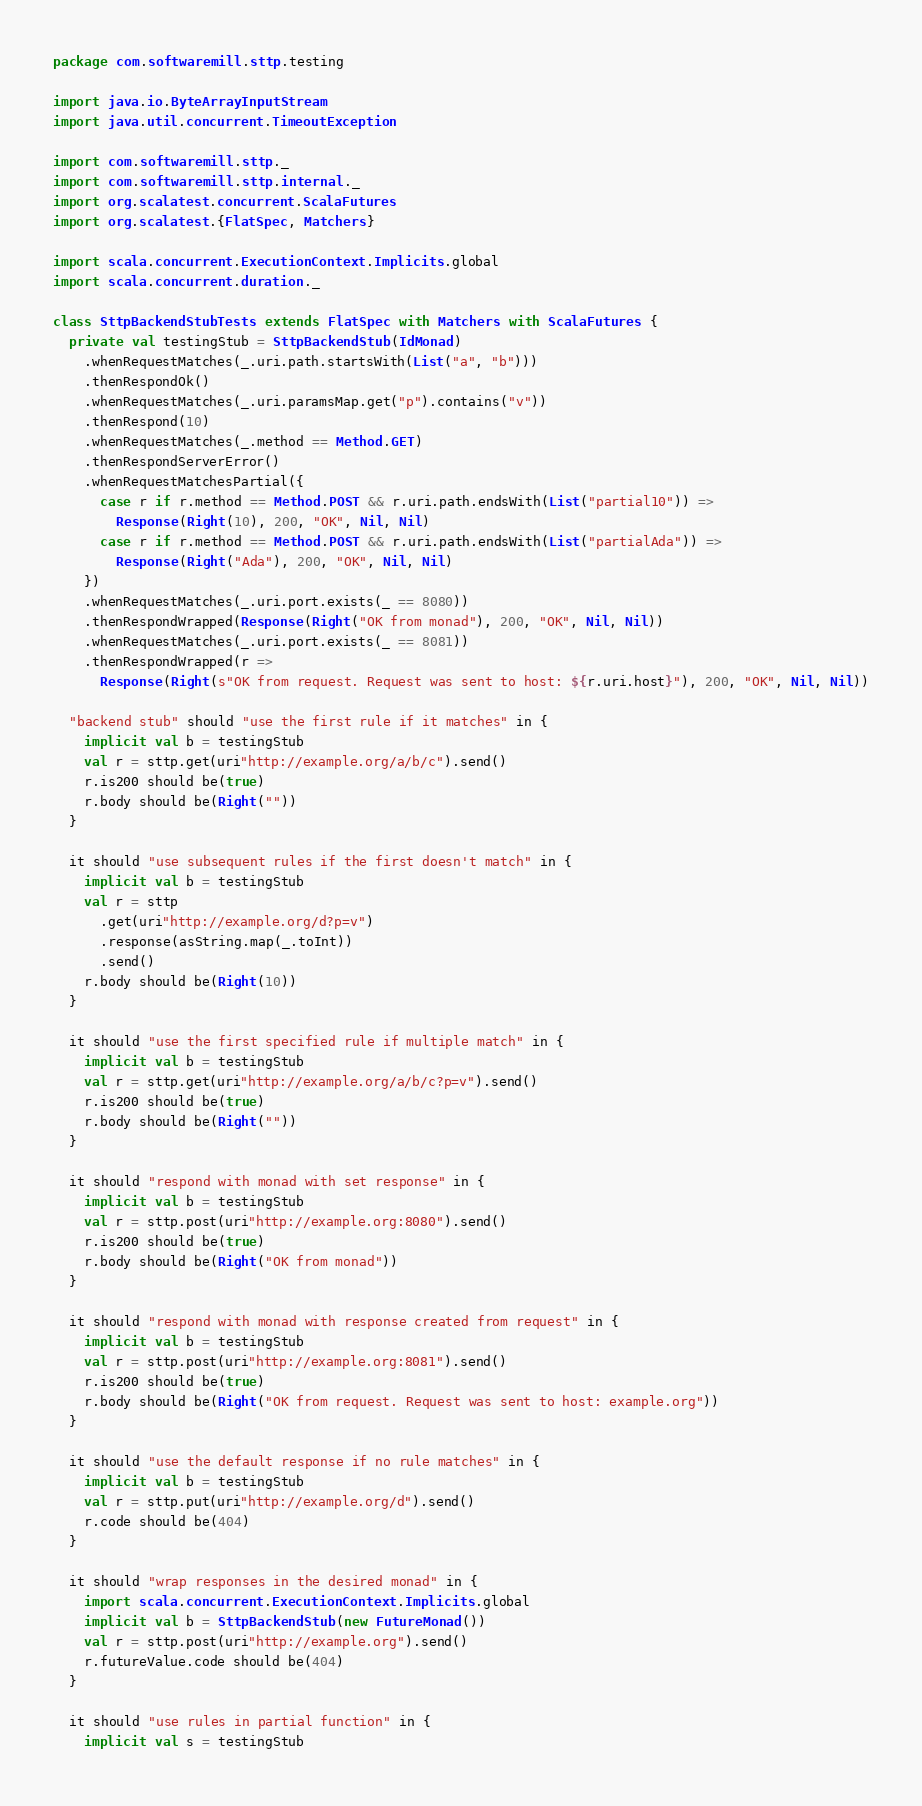Convert code to text. <code><loc_0><loc_0><loc_500><loc_500><_Scala_>package com.softwaremill.sttp.testing

import java.io.ByteArrayInputStream
import java.util.concurrent.TimeoutException

import com.softwaremill.sttp._
import com.softwaremill.sttp.internal._
import org.scalatest.concurrent.ScalaFutures
import org.scalatest.{FlatSpec, Matchers}

import scala.concurrent.ExecutionContext.Implicits.global
import scala.concurrent.duration._

class SttpBackendStubTests extends FlatSpec with Matchers with ScalaFutures {
  private val testingStub = SttpBackendStub(IdMonad)
    .whenRequestMatches(_.uri.path.startsWith(List("a", "b")))
    .thenRespondOk()
    .whenRequestMatches(_.uri.paramsMap.get("p").contains("v"))
    .thenRespond(10)
    .whenRequestMatches(_.method == Method.GET)
    .thenRespondServerError()
    .whenRequestMatchesPartial({
      case r if r.method == Method.POST && r.uri.path.endsWith(List("partial10")) =>
        Response(Right(10), 200, "OK", Nil, Nil)
      case r if r.method == Method.POST && r.uri.path.endsWith(List("partialAda")) =>
        Response(Right("Ada"), 200, "OK", Nil, Nil)
    })
    .whenRequestMatches(_.uri.port.exists(_ == 8080))
    .thenRespondWrapped(Response(Right("OK from monad"), 200, "OK", Nil, Nil))
    .whenRequestMatches(_.uri.port.exists(_ == 8081))
    .thenRespondWrapped(r =>
      Response(Right(s"OK from request. Request was sent to host: ${r.uri.host}"), 200, "OK", Nil, Nil))

  "backend stub" should "use the first rule if it matches" in {
    implicit val b = testingStub
    val r = sttp.get(uri"http://example.org/a/b/c").send()
    r.is200 should be(true)
    r.body should be(Right(""))
  }

  it should "use subsequent rules if the first doesn't match" in {
    implicit val b = testingStub
    val r = sttp
      .get(uri"http://example.org/d?p=v")
      .response(asString.map(_.toInt))
      .send()
    r.body should be(Right(10))
  }

  it should "use the first specified rule if multiple match" in {
    implicit val b = testingStub
    val r = sttp.get(uri"http://example.org/a/b/c?p=v").send()
    r.is200 should be(true)
    r.body should be(Right(""))
  }

  it should "respond with monad with set response" in {
    implicit val b = testingStub
    val r = sttp.post(uri"http://example.org:8080").send()
    r.is200 should be(true)
    r.body should be(Right("OK from monad"))
  }

  it should "respond with monad with response created from request" in {
    implicit val b = testingStub
    val r = sttp.post(uri"http://example.org:8081").send()
    r.is200 should be(true)
    r.body should be(Right("OK from request. Request was sent to host: example.org"))
  }

  it should "use the default response if no rule matches" in {
    implicit val b = testingStub
    val r = sttp.put(uri"http://example.org/d").send()
    r.code should be(404)
  }

  it should "wrap responses in the desired monad" in {
    import scala.concurrent.ExecutionContext.Implicits.global
    implicit val b = SttpBackendStub(new FutureMonad())
    val r = sttp.post(uri"http://example.org").send()
    r.futureValue.code should be(404)
  }

  it should "use rules in partial function" in {
    implicit val s = testingStub</code> 